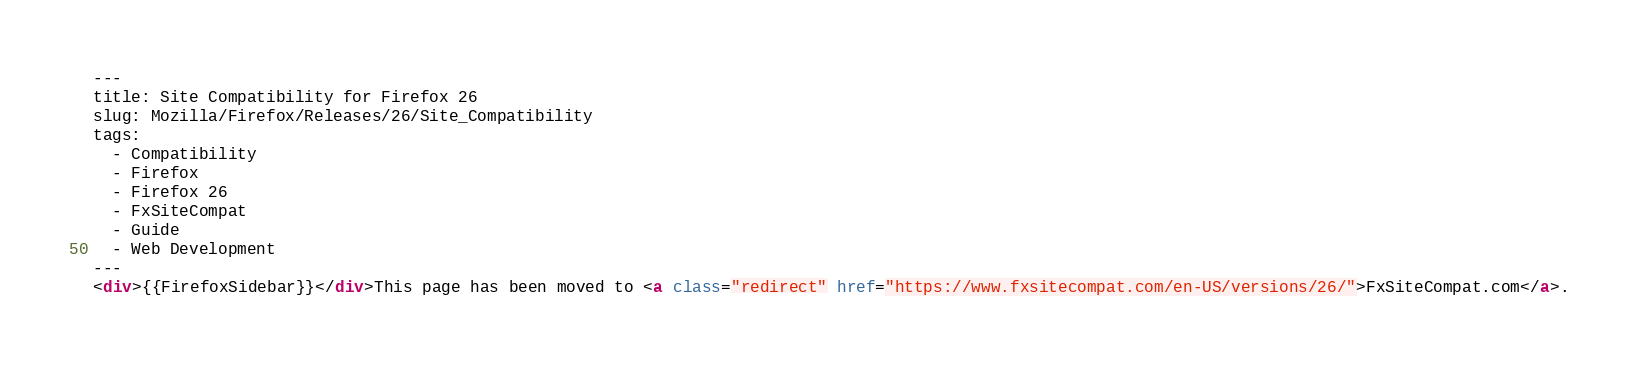<code> <loc_0><loc_0><loc_500><loc_500><_HTML_>---
title: Site Compatibility for Firefox 26
slug: Mozilla/Firefox/Releases/26/Site_Compatibility
tags:
  - Compatibility
  - Firefox
  - Firefox 26
  - FxSiteCompat
  - Guide
  - Web Development
---
<div>{{FirefoxSidebar}}</div>This page has been moved to <a class="redirect" href="https://www.fxsitecompat.com/en-US/versions/26/">FxSiteCompat.com</a>.
</code> 